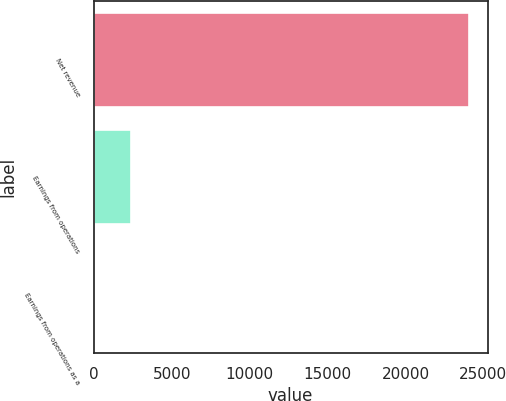Convert chart. <chart><loc_0><loc_0><loc_500><loc_500><bar_chart><fcel>Net revenue<fcel>Earnings from operations<fcel>Earnings from operations as a<nl><fcel>24061<fcel>2408.62<fcel>2.8<nl></chart> 